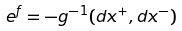<formula> <loc_0><loc_0><loc_500><loc_500>e ^ { f } = - g ^ { - 1 } ( d x ^ { + } , d x ^ { - } )</formula> 